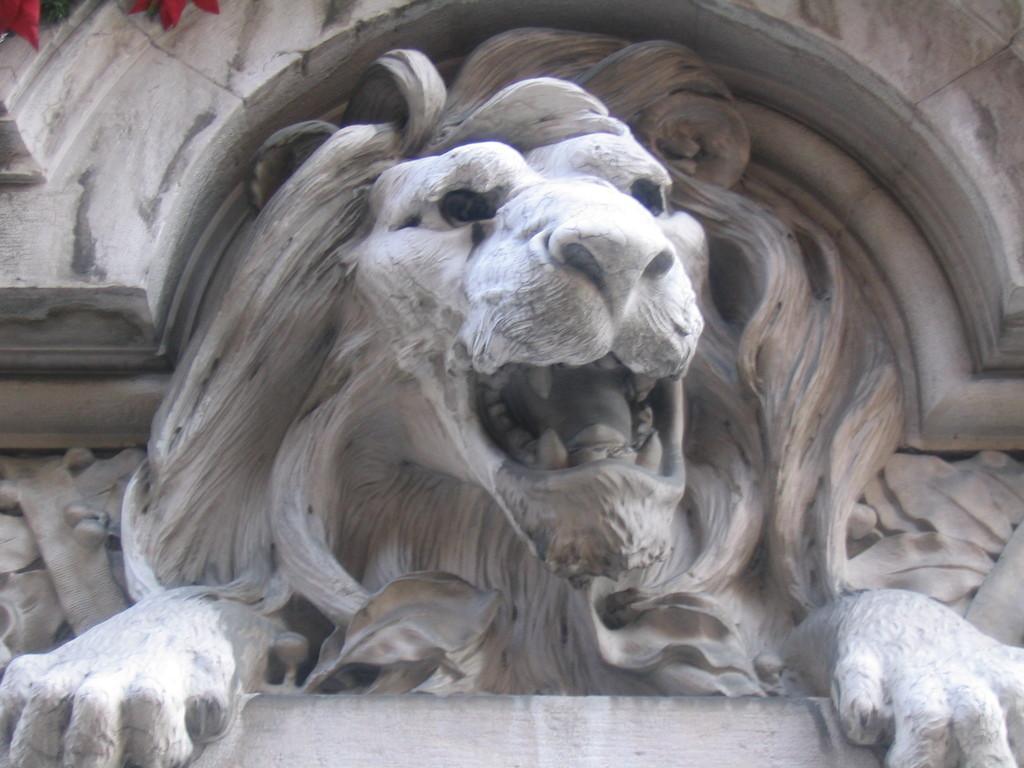How would you summarize this image in a sentence or two? In the picture we can see sculpture of a lion which is on the wall. 